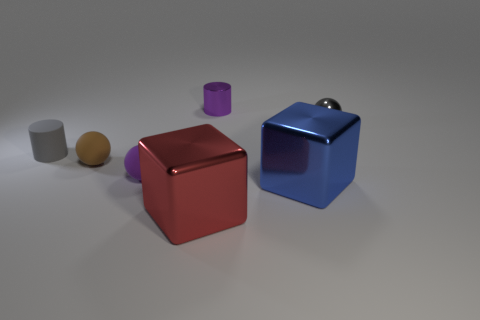There is a blue metal object; is it the same shape as the metal thing to the left of the small purple cylinder?
Offer a very short reply. Yes. What material is the tiny thing that is behind the small ball on the right side of the tiny cylinder on the right side of the gray matte cylinder?
Offer a terse response. Metal. What number of other things are there of the same size as the blue cube?
Offer a terse response. 1. Is the matte cylinder the same color as the small metal ball?
Your response must be concise. Yes. There is a tiny gray thing that is on the left side of the small object in front of the brown rubber ball; what number of small cylinders are to the right of it?
Ensure brevity in your answer.  1. What material is the small purple thing in front of the tiny cylinder left of the small purple metallic object?
Your response must be concise. Rubber. Are there any small gray metal objects of the same shape as the red shiny thing?
Your answer should be very brief. No. There is a matte cylinder that is the same size as the purple sphere; what is its color?
Offer a terse response. Gray. How many objects are tiny metallic objects left of the large blue metallic block or metallic objects that are right of the big blue shiny cube?
Your response must be concise. 2. How many objects are large things or tiny brown objects?
Ensure brevity in your answer.  3. 